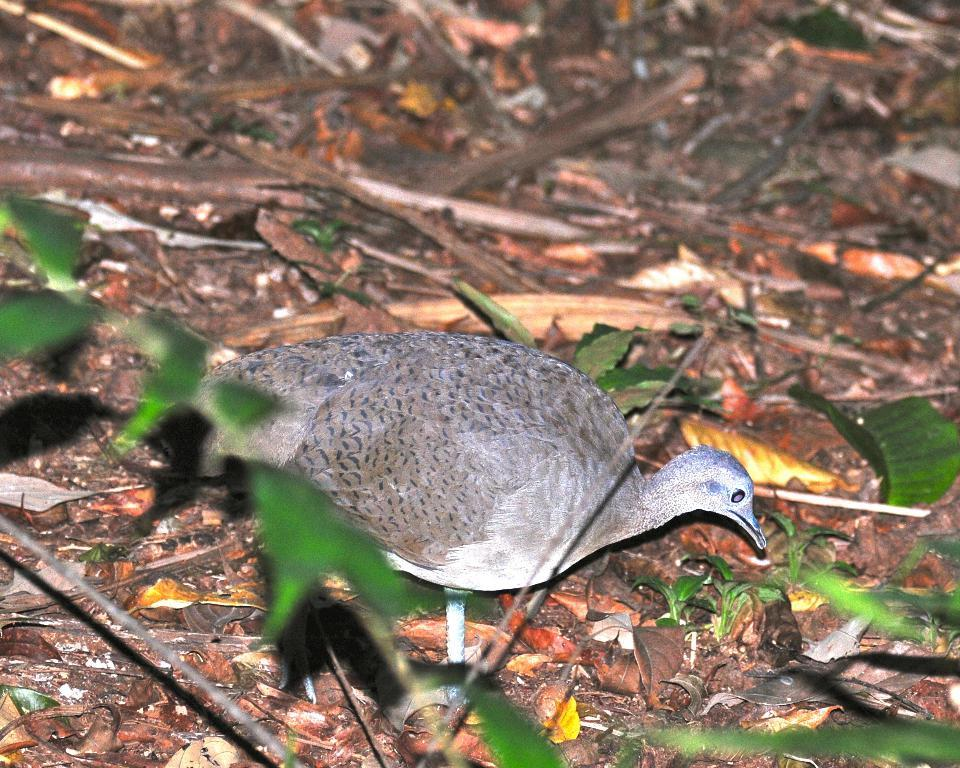What type of animal can be seen in the image? There is a bird in the image. What can be seen in the background of the image? There are dry leaves and woods in the background of the image. Are there any leaves visible at the bottom of the image? Yes, leaves are visible at the bottom of the image. What type of crate is visible in the office setting in the image? There is no crate or office setting present in the image; it features a bird and natural elements in the background. 